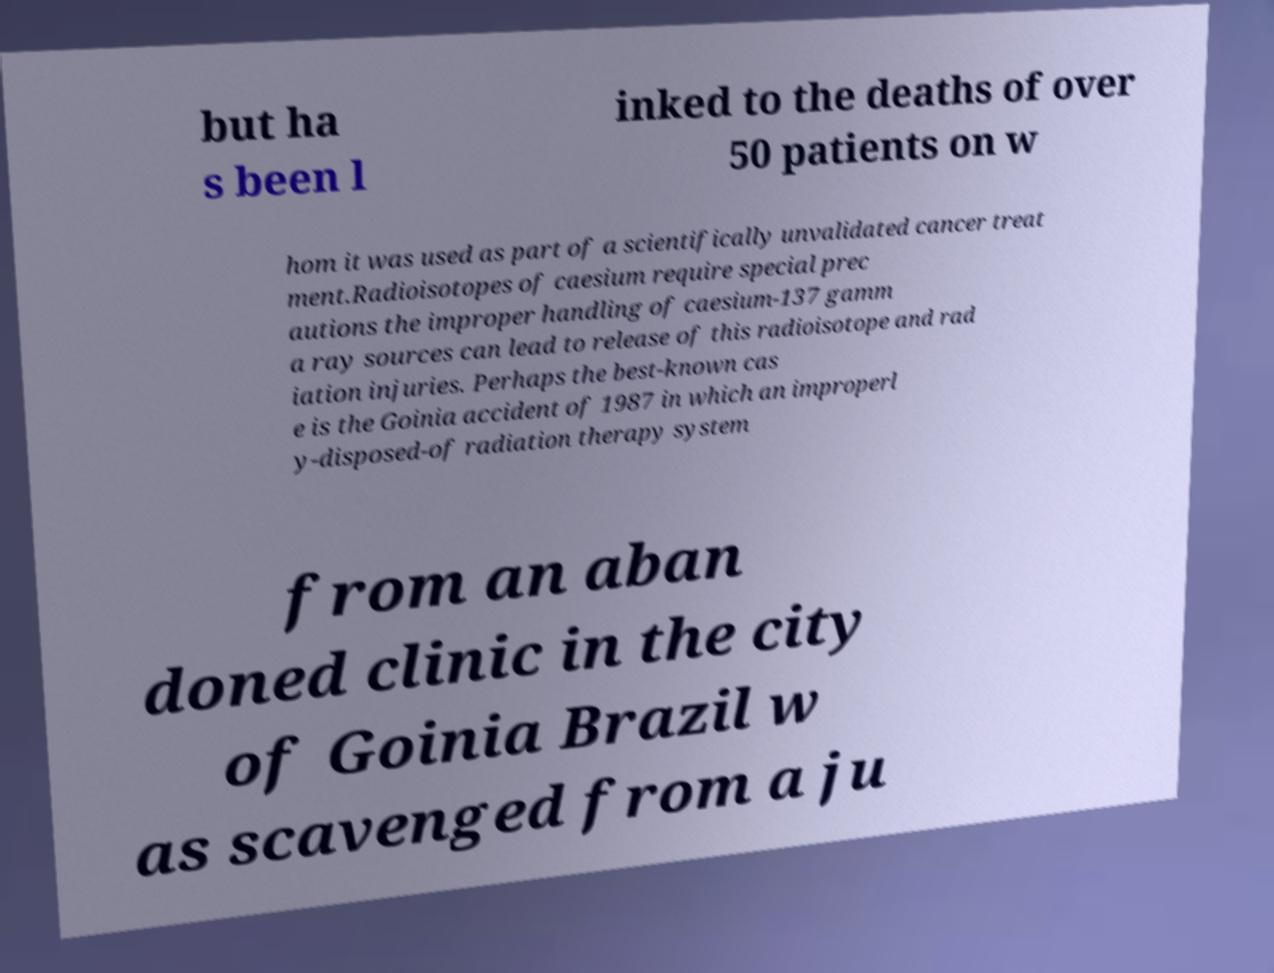Please read and relay the text visible in this image. What does it say? but ha s been l inked to the deaths of over 50 patients on w hom it was used as part of a scientifically unvalidated cancer treat ment.Radioisotopes of caesium require special prec autions the improper handling of caesium-137 gamm a ray sources can lead to release of this radioisotope and rad iation injuries. Perhaps the best-known cas e is the Goinia accident of 1987 in which an improperl y-disposed-of radiation therapy system from an aban doned clinic in the city of Goinia Brazil w as scavenged from a ju 